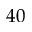Convert formula to latex. <formula><loc_0><loc_0><loc_500><loc_500>4 0</formula> 